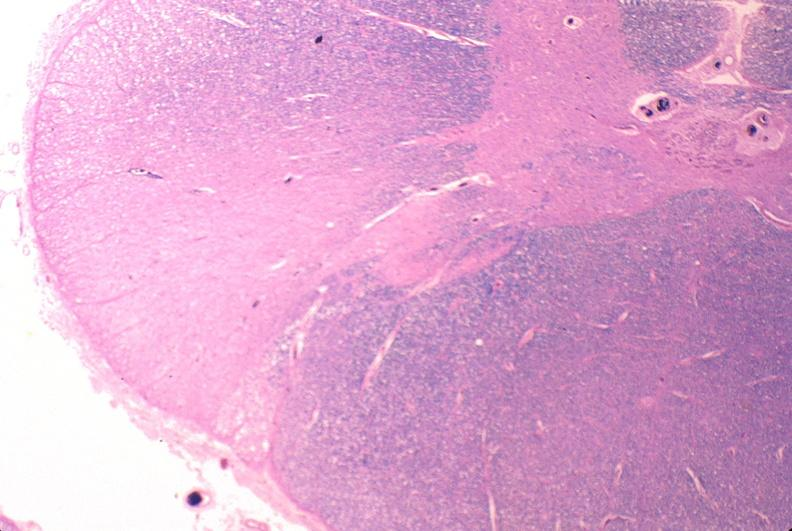s atrophy secondary to pituitectomy present?
Answer the question using a single word or phrase. No 